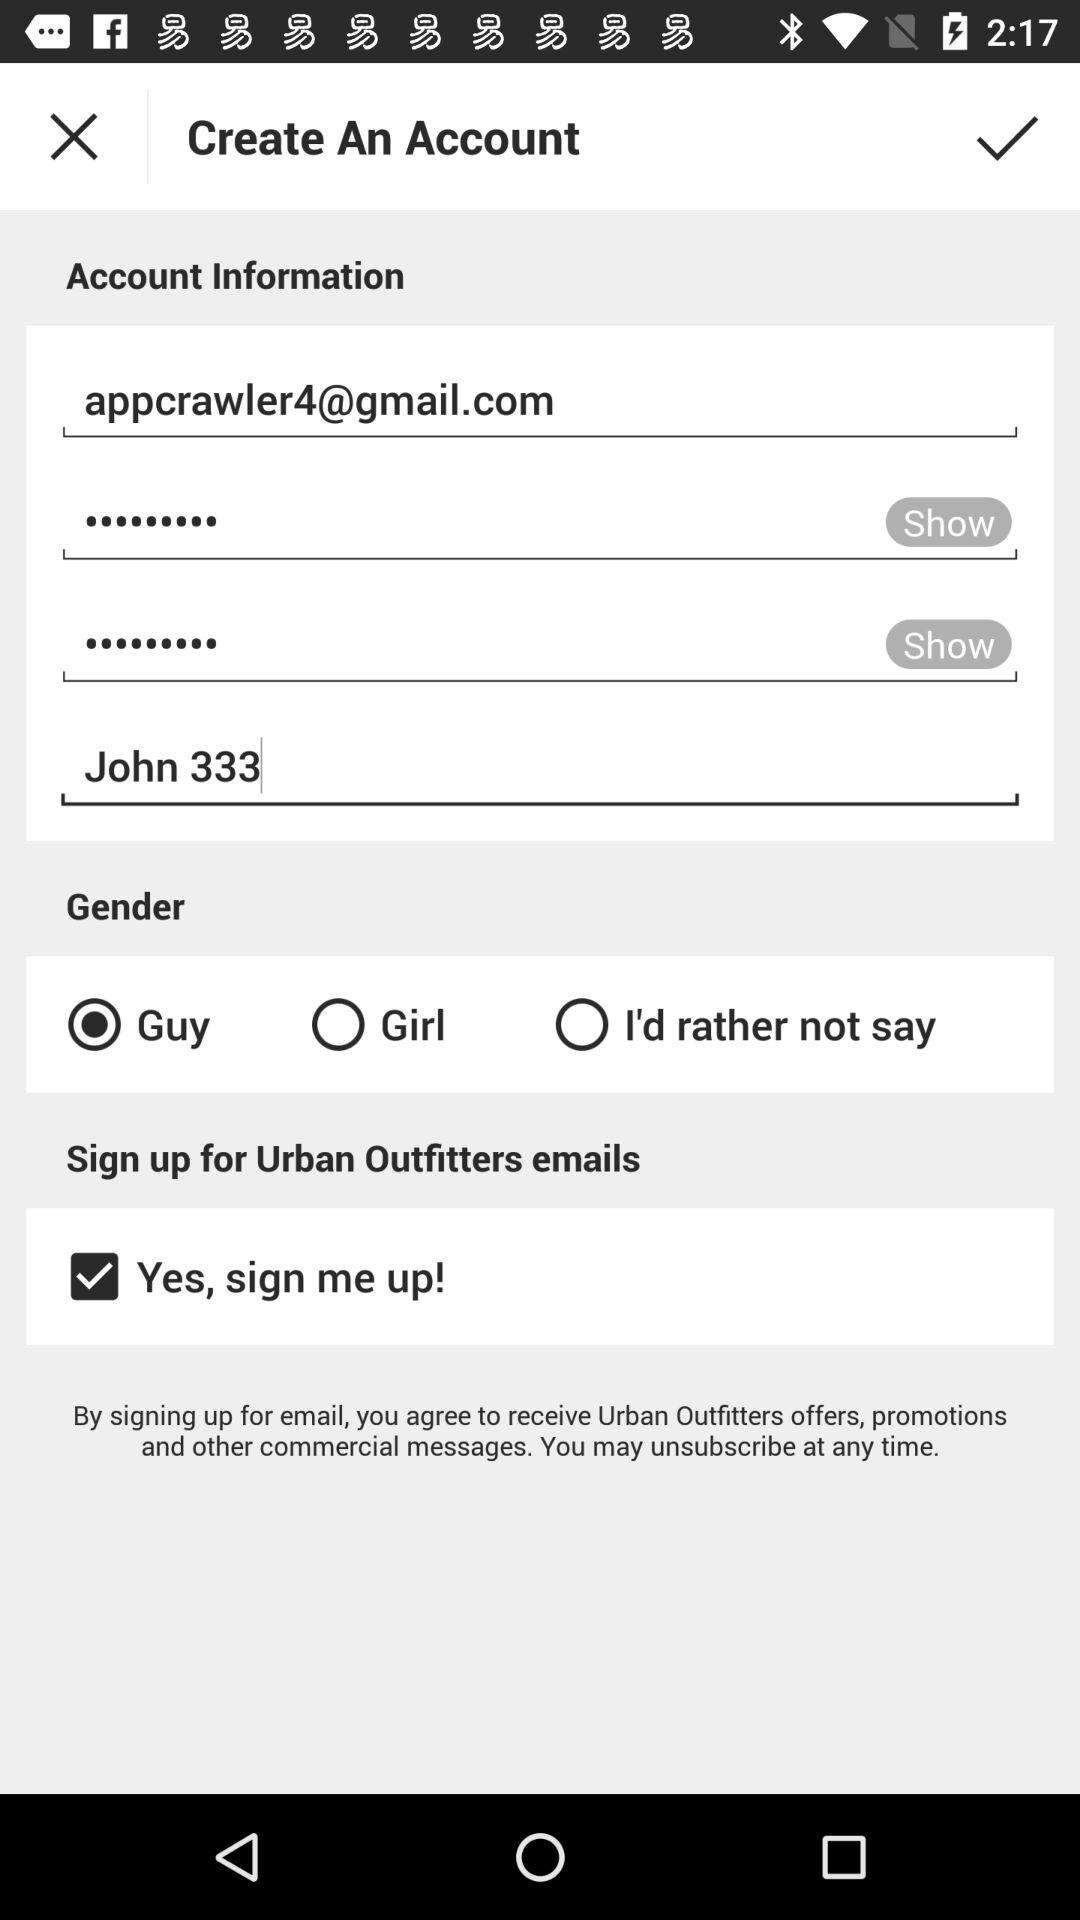Which are the options for choosing the gender? The options for choosing the gender are : "Guy", "Girl", and "I'd rather not say". 